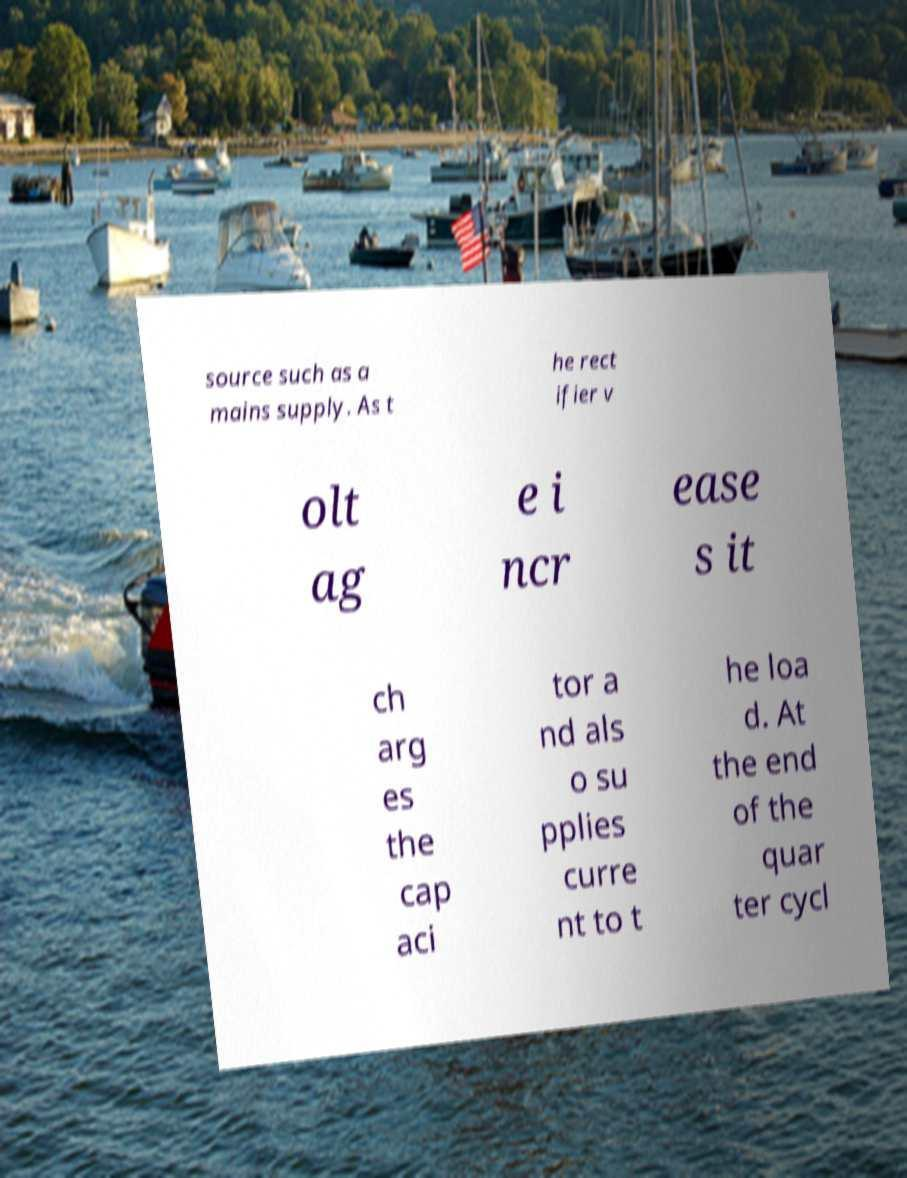What messages or text are displayed in this image? I need them in a readable, typed format. source such as a mains supply. As t he rect ifier v olt ag e i ncr ease s it ch arg es the cap aci tor a nd als o su pplies curre nt to t he loa d. At the end of the quar ter cycl 